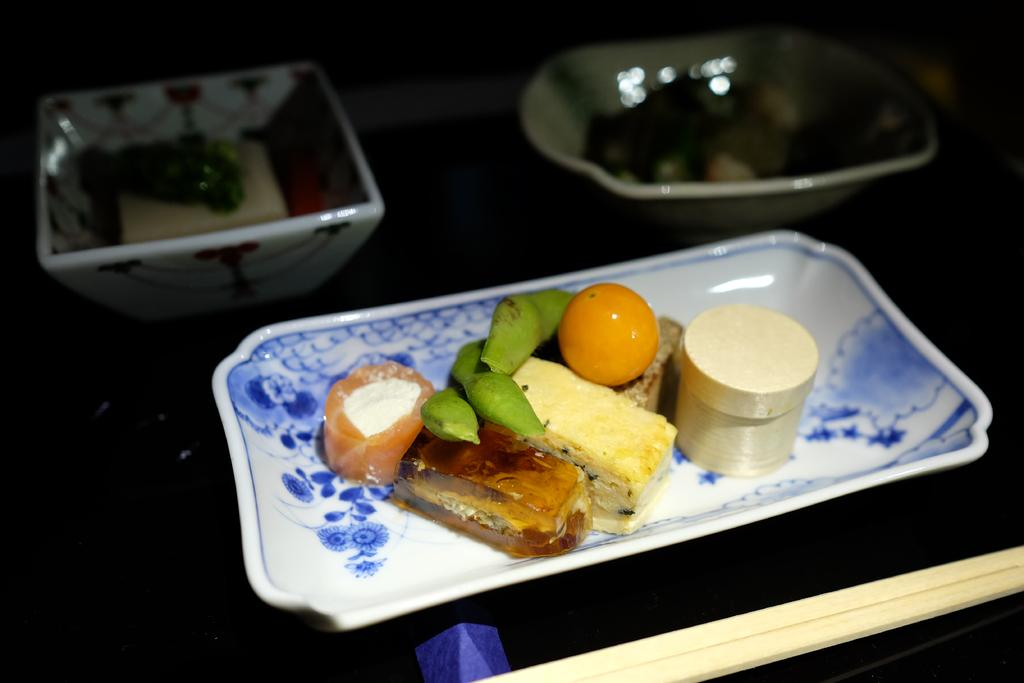What is located in the foreground of the picture? There is a table in the foreground of the picture. What objects are on the table? There is a bowl, a plate, and a platter on the table. Are there any other items related to serving or eating on the table? Yes, there are dishes on the table. What type of bread can be seen on the table in the image? There is no bread visible on the table in the image. 